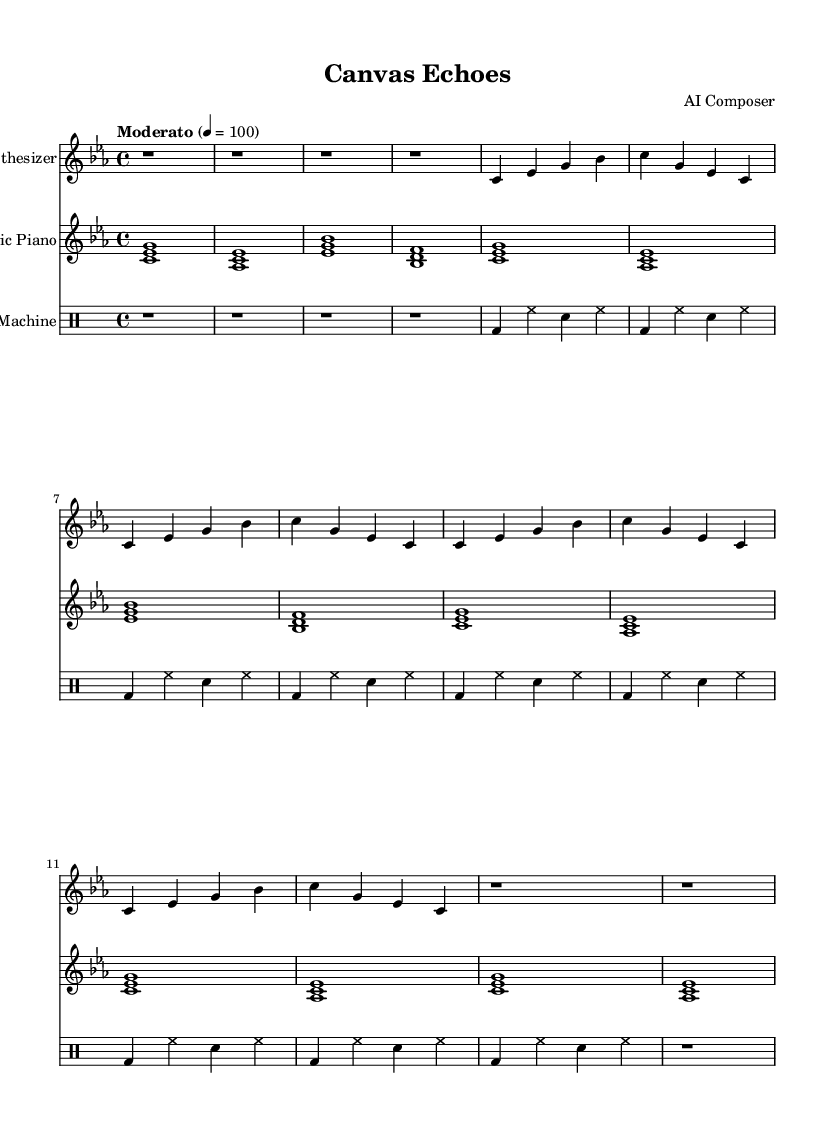What is the key signature of this music? The key signature is C minor, which has three flats (B♭, E♭, A♭). We can identify the key signature at the beginning of the score, where the flat symbols are placed.
Answer: C minor What is the time signature of this music? The time signature is 4/4, which indicates that there are four beats in each measure and a quarter note gets one beat. This is shown at the beginning of the sheet music next to the key signature.
Answer: 4/4 What is the tempo marking for this piece? The tempo marking is "Moderato," which suggests a moderate pace for the music. It is specified above the clef at the start of the score, along with the beats per minute indication.
Answer: Moderato How many sections are present in the piece? The piece includes three sections: Section A, Section B, and Section C, indicated in the music with distinct labeling. There is also an intro and an outro but they are not labeled as specific sections.
Answer: Three Which instrument plays the melody in the first section? The synthesizer plays the melody in the first section, as indicated in the staff name and the notes presented in Section A, which is associated with the synthesizer part.
Answer: Synthesizer What type of rhythm is primarily used in the drum machine part? The primary rhythm in the drum machine part consists of bass drum, hi-hat, and snare drum patterns, which are commonly represented in drum notation. The bass drum plays on the downbeats, creating a standard groove.
Answer: Bass drum, hi-hat, snare How does the electric piano complement the synthesizer in the piece? The electric piano complements the synthesizer by playing harmonic chords that support the melodic lines. In Section A, both instruments play similar rhythmic patterns while the electric piano adds depth with fuller chords.
Answer: Harmonic chords 